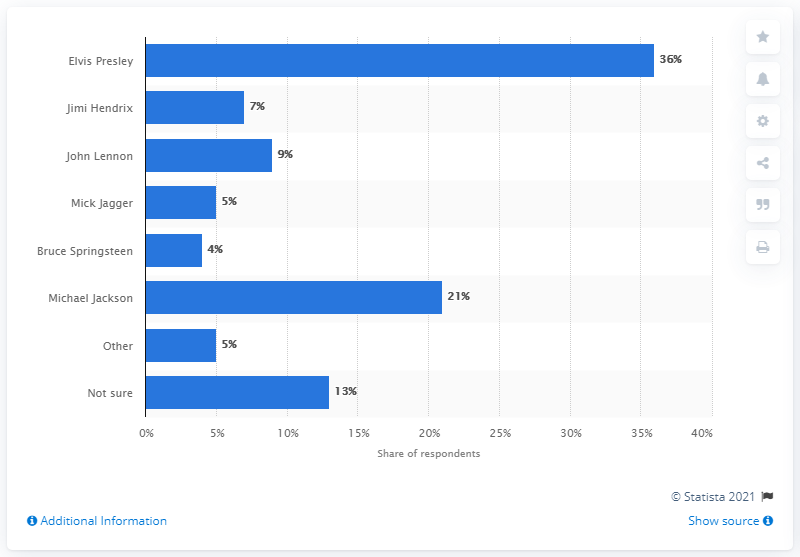Mention a couple of crucial points in this snapshot. According to the results of the survey, 36% of respondents believed that Elvis Presley was the greatest rock'n'roll star of all time. 